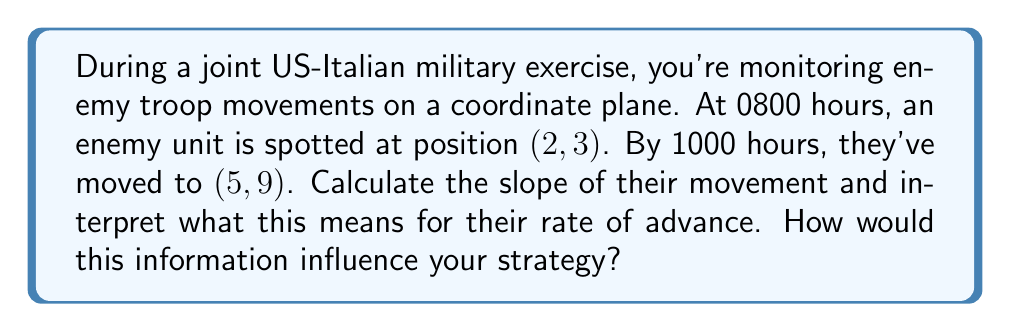Give your solution to this math problem. To solve this problem, we'll follow these steps:

1) First, let's recall the slope formula:
   
   $$ m = \frac{y_2 - y_1}{x_2 - x_1} $$

   where $(x_1, y_1)$ is the initial position and $(x_2, y_2)$ is the final position.

2) We have:
   Initial position $(x_1, y_1) = (2, 3)$
   Final position $(x_2, y_2) = (5, 9)$

3) Let's plug these into our slope formula:

   $$ m = \frac{9 - 3}{5 - 2} = \frac{6}{3} = 2 $$

4) Interpretation:
   The slope of 2 means that for every 1 unit the enemy moves horizontally, they move 2 units vertically.

5) To calculate the rate of advance:
   Horizontal distance covered: $5 - 2 = 3$ units
   Vertical distance covered: $9 - 3 = 6$ units
   Time taken: 2 hours (from 0800 to 1000)

   Rate of horizontal advance: $\frac{3 \text{ units}}{2 \text{ hours}} = 1.5 \text{ units/hour}$
   Rate of vertical advance: $\frac{6 \text{ units}}{2 \text{ hours}} = 3 \text{ units/hour}$

6) Strategy implications:
   The enemy is moving twice as fast vertically as horizontally, suggesting they might be heading towards higher ground or a specific vertical objective. This rapid vertical movement could indicate they're trying to gain a tactical height advantage or reach a specific target quickly.
Answer: The slope of the enemy's movement is 2. This indicates they are advancing vertically twice as fast as horizontally, with a horizontal rate of 1.5 units/hour and a vertical rate of 3 units/hour. Strategically, this suggests a possible attempt to gain higher ground or reach a vertical objective quickly. 